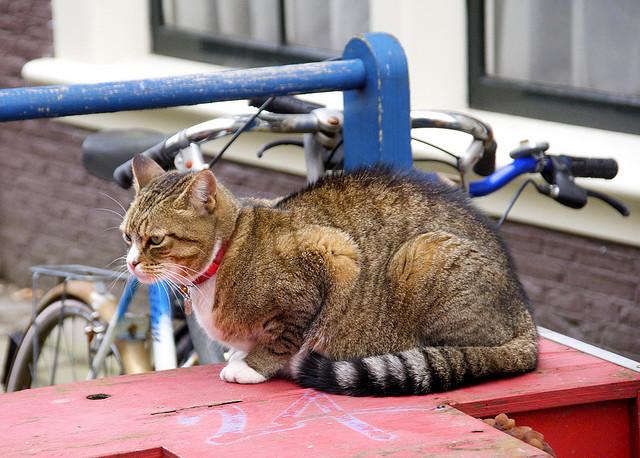Is the cat playing?
Concise answer only. No. Is the cat wearing a collar?
Answer briefly. Yes. Was this picture taken outside a house?
Quick response, please. Yes. 